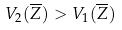Convert formula to latex. <formula><loc_0><loc_0><loc_500><loc_500>V _ { 2 } ( \overline { Z } ) > V _ { 1 } ( \overline { Z } )</formula> 